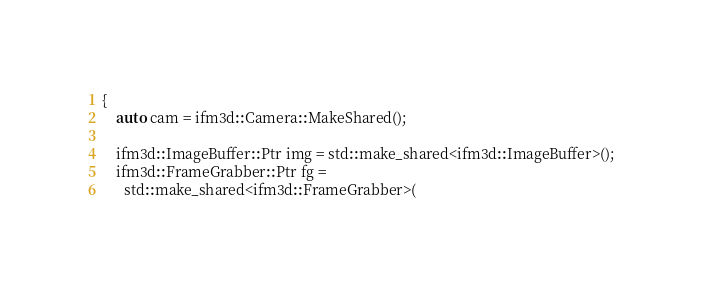<code> <loc_0><loc_0><loc_500><loc_500><_C++_>{
    auto cam = ifm3d::Camera::MakeShared();

    ifm3d::ImageBuffer::Ptr img = std::make_shared<ifm3d::ImageBuffer>();
    ifm3d::FrameGrabber::Ptr fg =
      std::make_shared<ifm3d::FrameGrabber>(</code> 